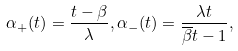<formula> <loc_0><loc_0><loc_500><loc_500>\alpha _ { + } ( t ) = \frac { t - \beta } { \lambda } , \alpha _ { - } ( t ) = \frac { \lambda t } { \overline { \beta } t - 1 } ,</formula> 